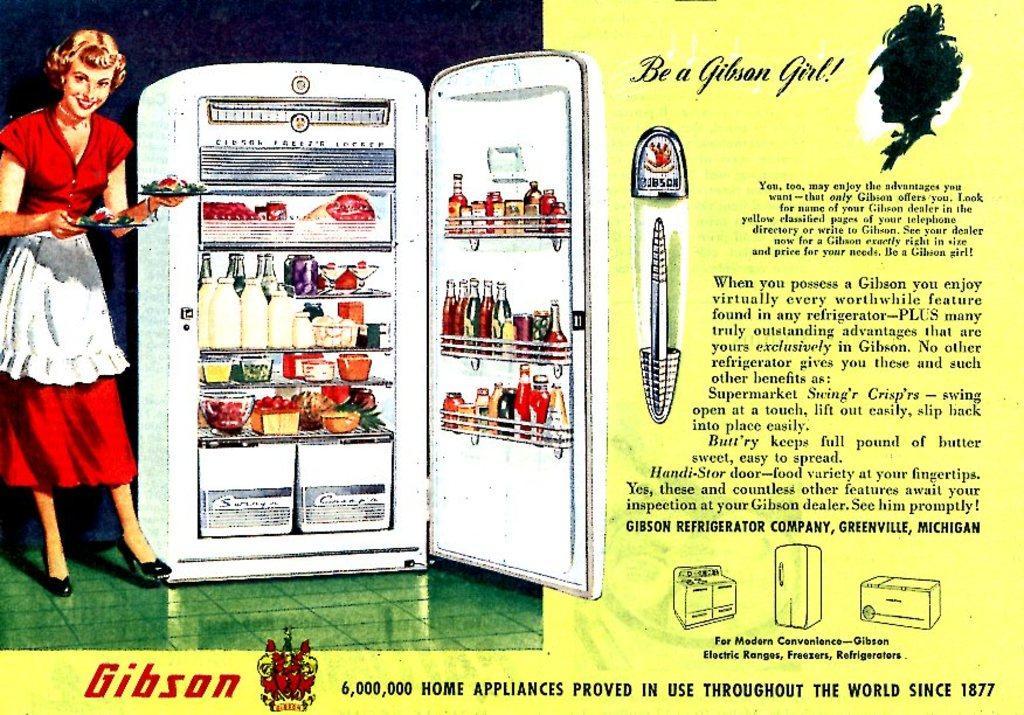How would you summarize this image in a sentence or two? In this image we can see a poster with text and images on the right side of the image and on the left there is a fridge with bottles and food items in the fridge and a woman holding plates with food beside the fridge. 